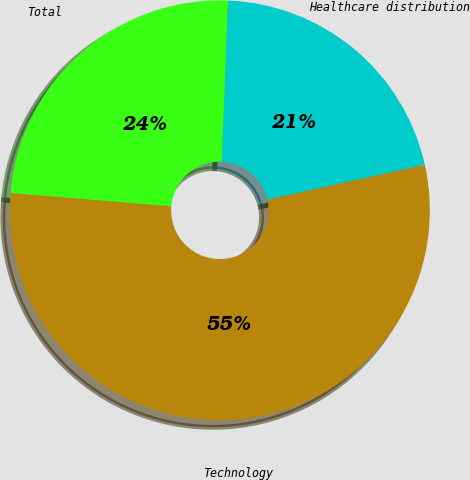Convert chart. <chart><loc_0><loc_0><loc_500><loc_500><pie_chart><fcel>Healthcare distribution<fcel>Technology<fcel>Total<nl><fcel>20.91%<fcel>54.79%<fcel>24.3%<nl></chart> 